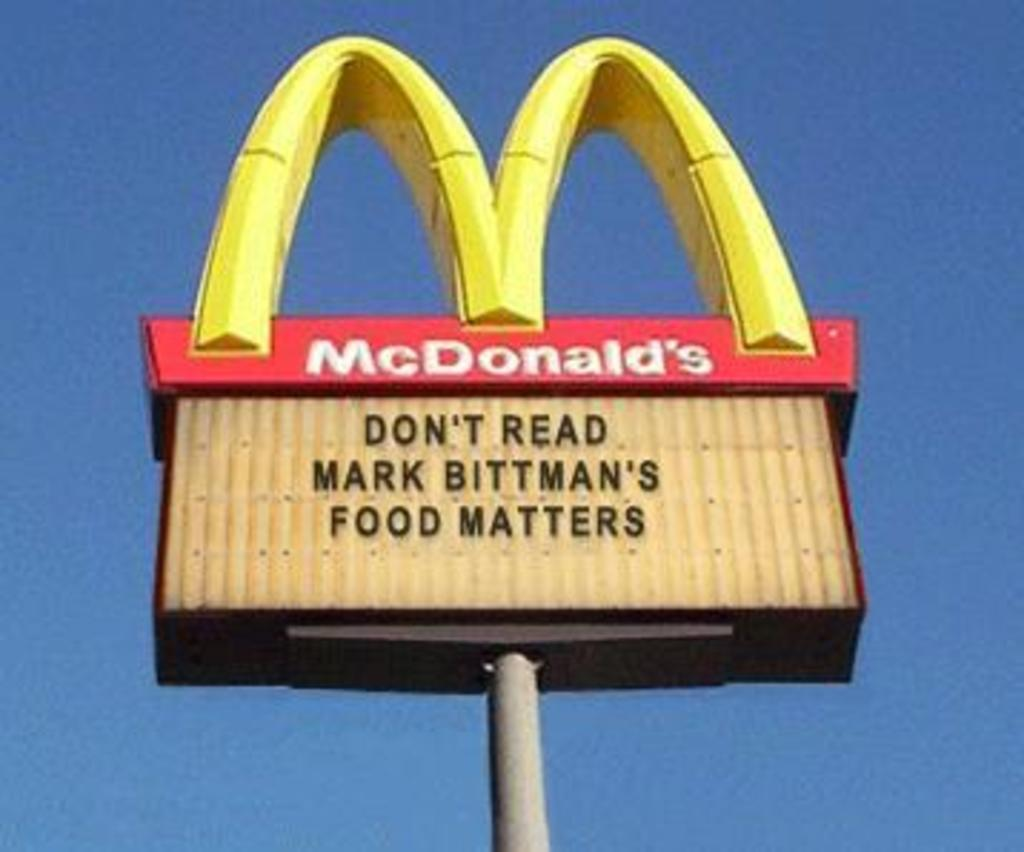Provide a one-sentence caption for the provided image. A McDonald's sign encourages people not to read Mark Bittman's book. 